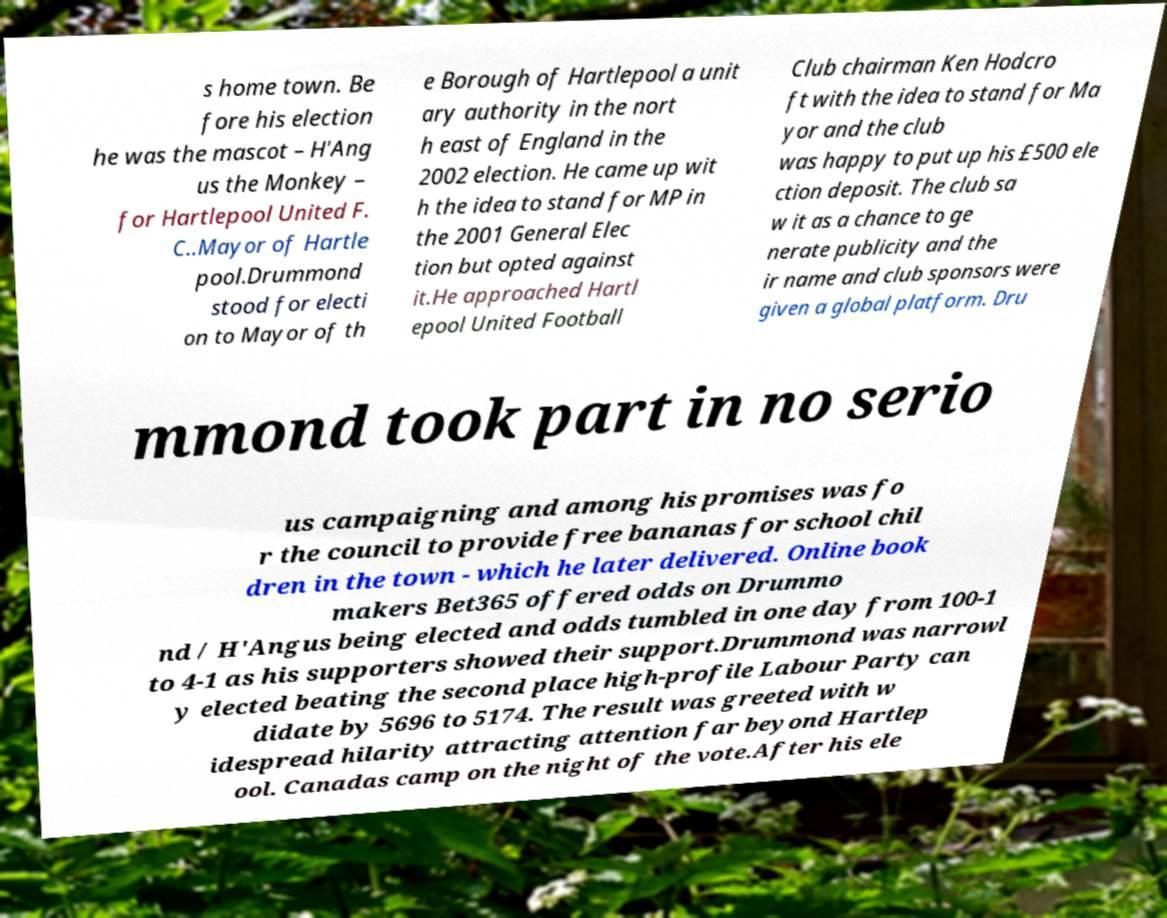What messages or text are displayed in this image? I need them in a readable, typed format. s home town. Be fore his election he was the mascot – H'Ang us the Monkey – for Hartlepool United F. C..Mayor of Hartle pool.Drummond stood for electi on to Mayor of th e Borough of Hartlepool a unit ary authority in the nort h east of England in the 2002 election. He came up wit h the idea to stand for MP in the 2001 General Elec tion but opted against it.He approached Hartl epool United Football Club chairman Ken Hodcro ft with the idea to stand for Ma yor and the club was happy to put up his £500 ele ction deposit. The club sa w it as a chance to ge nerate publicity and the ir name and club sponsors were given a global platform. Dru mmond took part in no serio us campaigning and among his promises was fo r the council to provide free bananas for school chil dren in the town - which he later delivered. Online book makers Bet365 offered odds on Drummo nd / H'Angus being elected and odds tumbled in one day from 100-1 to 4-1 as his supporters showed their support.Drummond was narrowl y elected beating the second place high-profile Labour Party can didate by 5696 to 5174. The result was greeted with w idespread hilarity attracting attention far beyond Hartlep ool. Canadas camp on the night of the vote.After his ele 